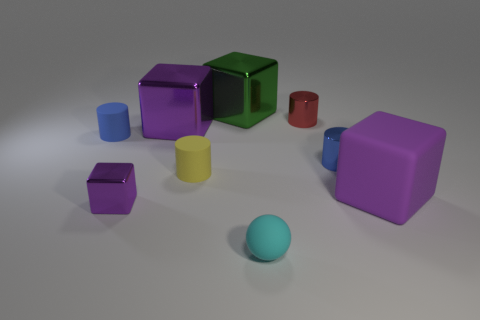There is another large cube that is the same color as the big rubber block; what material is it?
Ensure brevity in your answer.  Metal. How many other cylinders have the same material as the yellow cylinder?
Your answer should be compact. 1. What color is the block that is made of the same material as the tiny cyan sphere?
Your response must be concise. Purple. There is a metallic block that is in front of the purple rubber thing; is its size the same as the matte sphere?
Offer a terse response. Yes. There is another matte thing that is the same shape as the yellow object; what is its color?
Provide a short and direct response. Blue. There is a tiny rubber object behind the rubber cylinder on the right side of the blue cylinder behind the tiny blue metal cylinder; what is its shape?
Your answer should be very brief. Cylinder. Do the small red object and the big green thing have the same shape?
Your response must be concise. No. What is the shape of the big purple thing that is behind the small blue object on the right side of the green block?
Your answer should be compact. Cube. Are there any gray matte cubes?
Make the answer very short. No. How many yellow cylinders are in front of the tiny rubber ball that is to the left of the purple thing to the right of the green thing?
Give a very brief answer. 0. 